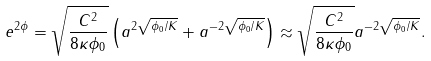Convert formula to latex. <formula><loc_0><loc_0><loc_500><loc_500>e ^ { 2 \phi } = \sqrt { \frac { C ^ { 2 } } { 8 \kappa \phi _ { 0 } } } \left ( a ^ { 2 \sqrt { \phi _ { 0 } / K } } + a ^ { - 2 \sqrt { \phi _ { 0 } / K } } \right ) \approx \sqrt { \frac { C ^ { 2 } } { 8 \kappa \phi _ { 0 } } } a ^ { - 2 \sqrt { \phi _ { 0 } / K } } .</formula> 